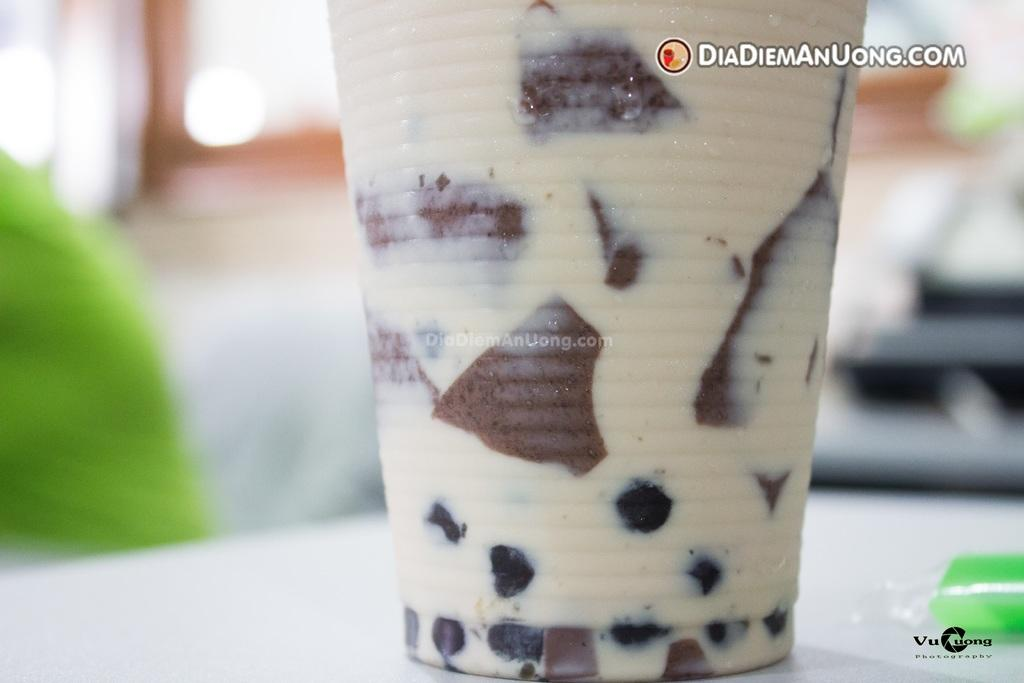What object is visible in the image that can hold a liquid? There is a glass in the image. On what surface is the glass placed? The glass is placed on a white color table. What colors are mentioned in the image? There are white and black color words in the image. How would you describe the background of the image? The background of the image is blurred. What type of pleasure can be seen in the image? There is no pleasure visible in the image; it features a glass on a table with blurred background and white and black color words. 